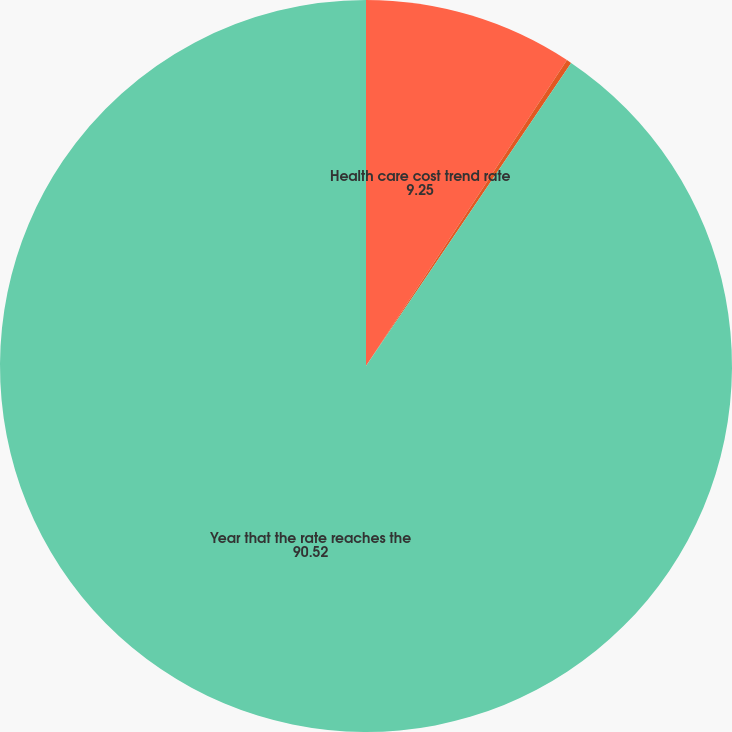Convert chart to OTSL. <chart><loc_0><loc_0><loc_500><loc_500><pie_chart><fcel>Health care cost trend rate<fcel>Rate that the cost trend rate<fcel>Year that the rate reaches the<nl><fcel>9.25%<fcel>0.22%<fcel>90.52%<nl></chart> 